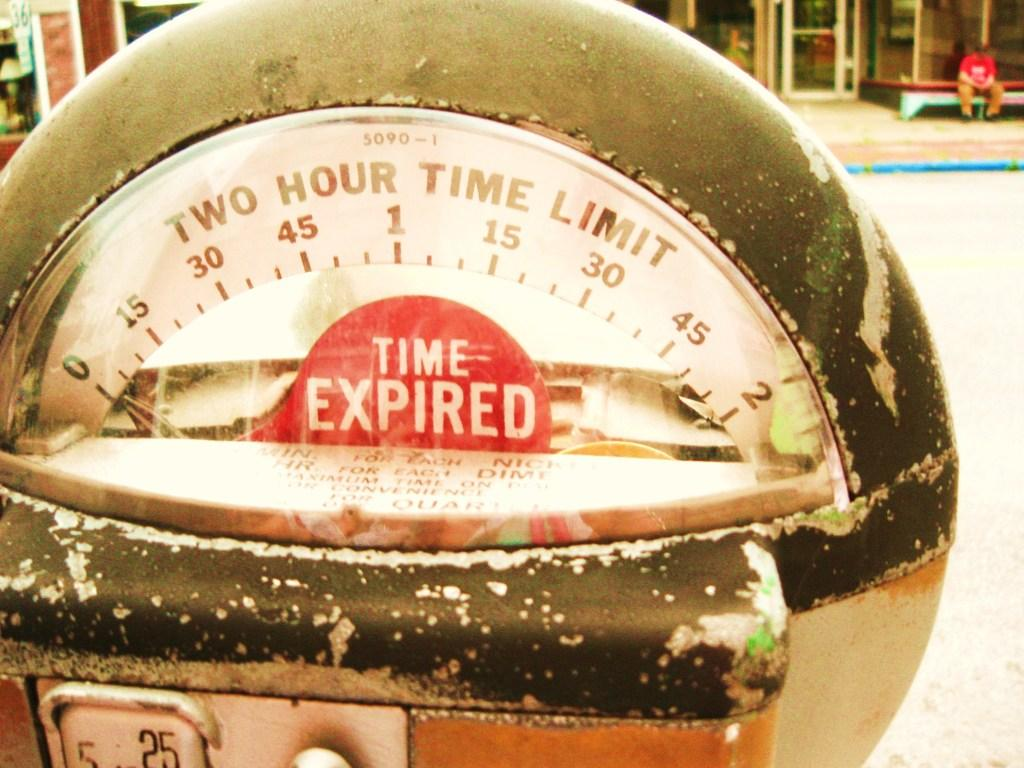<image>
Give a short and clear explanation of the subsequent image. The time has expired on a parking meter. 